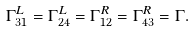<formula> <loc_0><loc_0><loc_500><loc_500>\Gamma _ { 3 1 } ^ { L } = \Gamma _ { 2 4 } ^ { L } = \Gamma _ { 1 2 } ^ { R } = \Gamma _ { 4 3 } ^ { R } = \Gamma .</formula> 